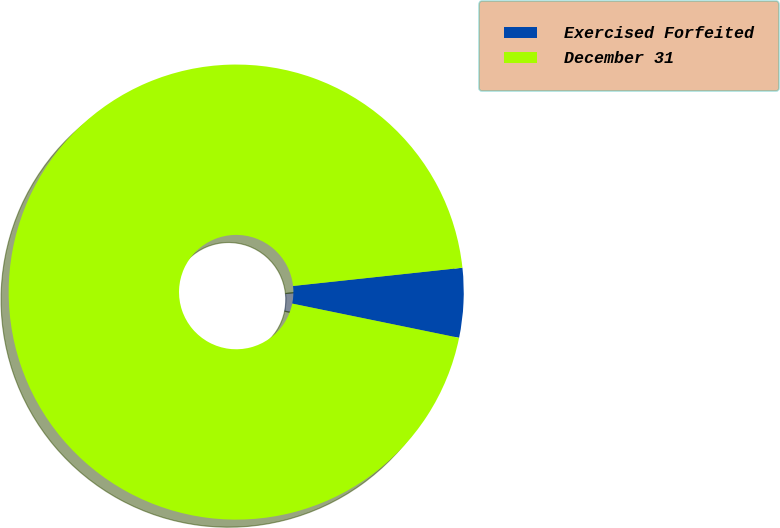Convert chart to OTSL. <chart><loc_0><loc_0><loc_500><loc_500><pie_chart><fcel>Exercised Forfeited<fcel>December 31<nl><fcel>4.93%<fcel>95.07%<nl></chart> 